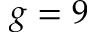Convert formula to latex. <formula><loc_0><loc_0><loc_500><loc_500>g = 9</formula> 